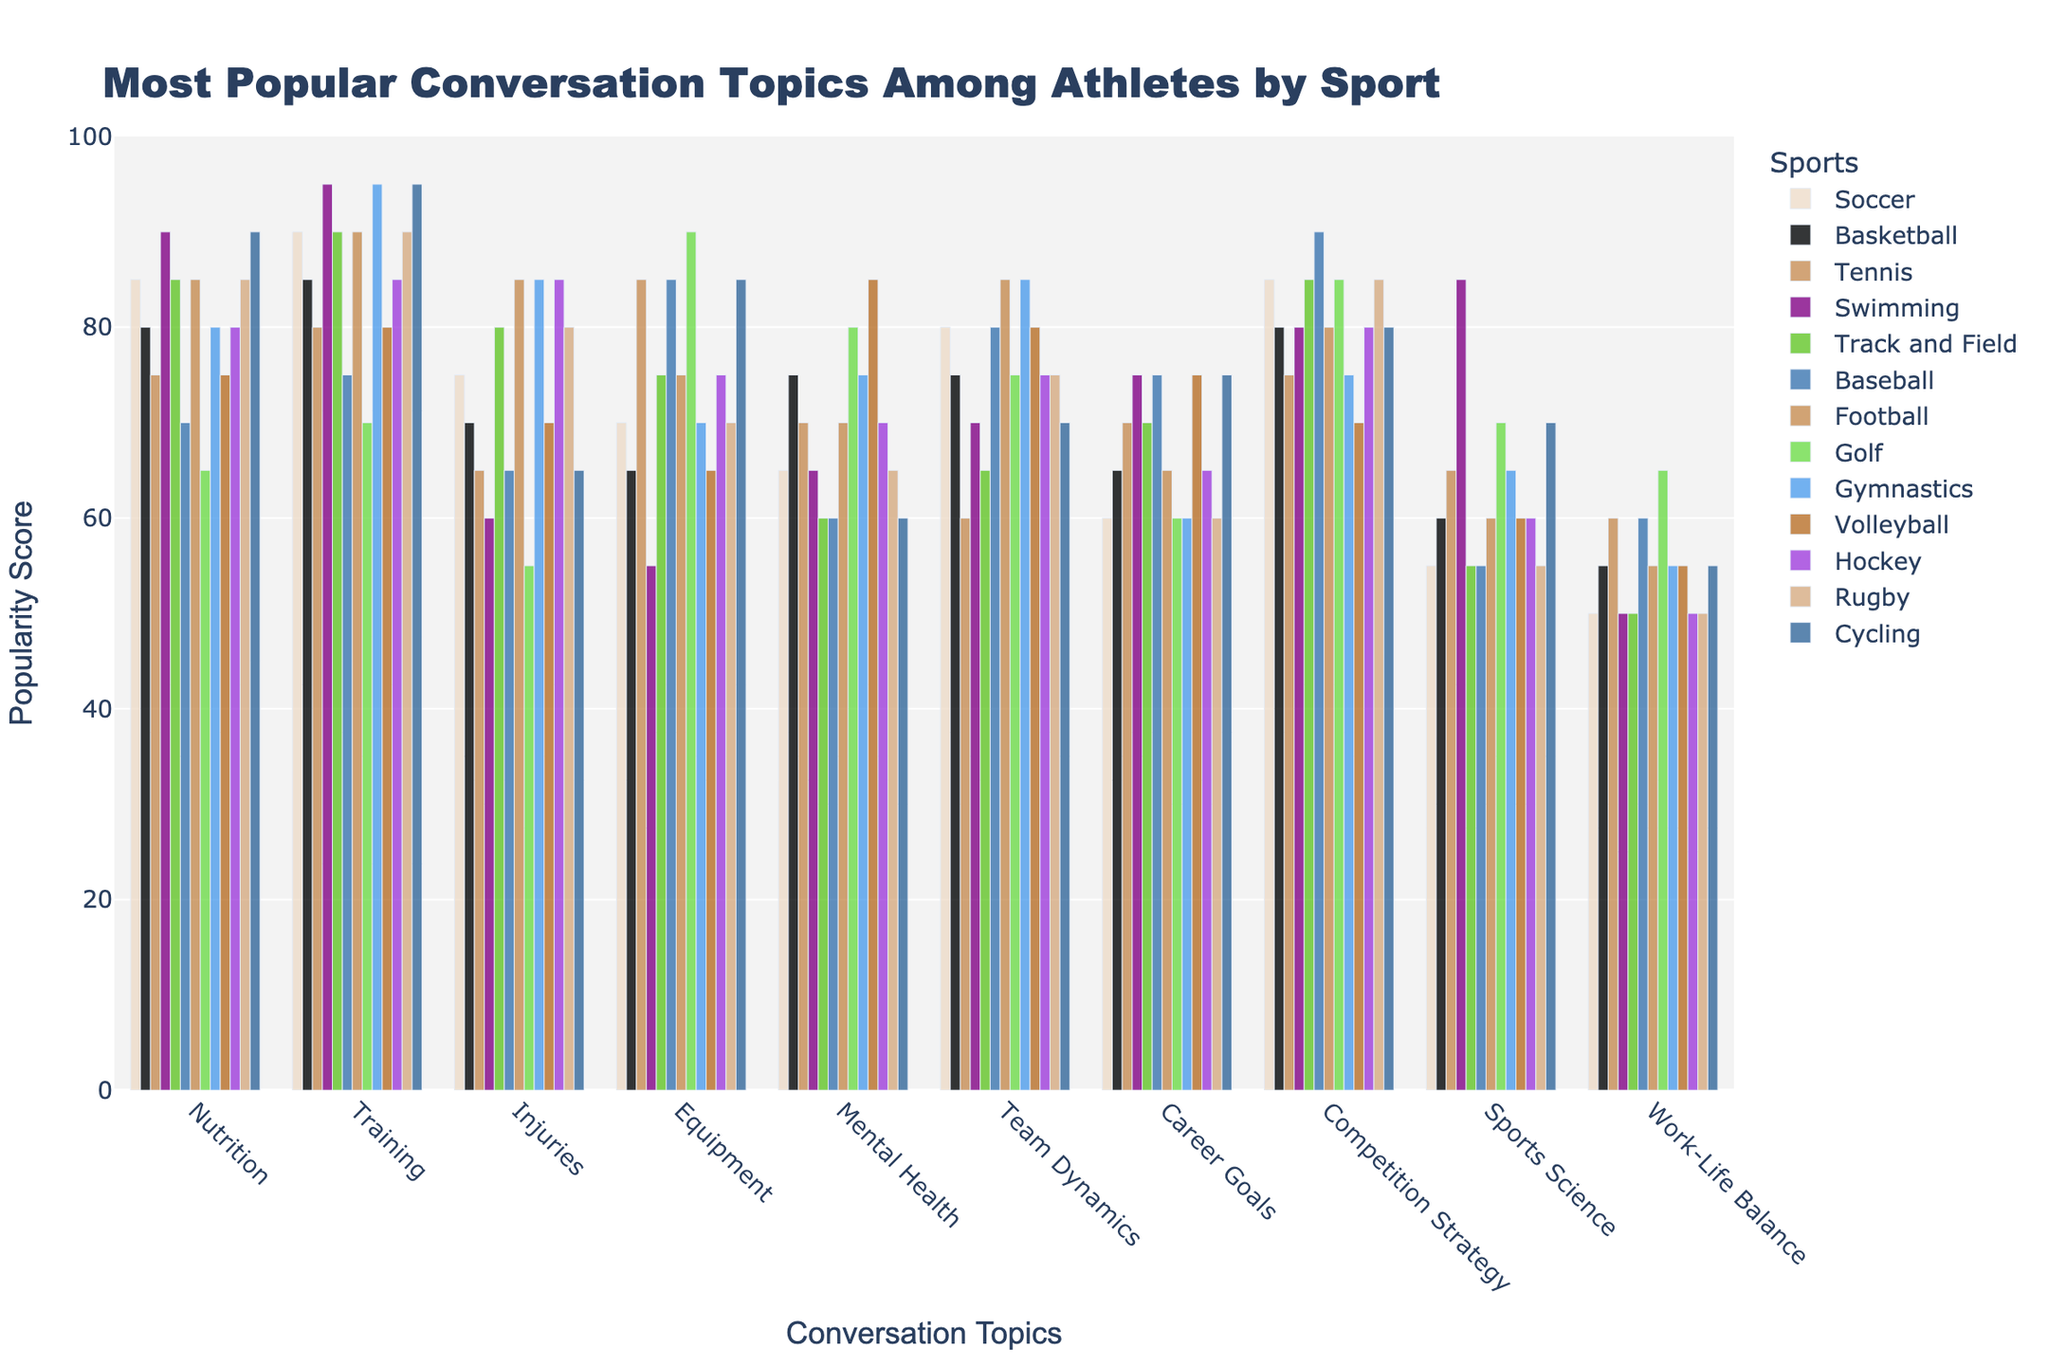Which sport has the highest popularity score for Mental Health? Soccer has a score of 65, Basketball 75, Tennis 70, Swimming 65, Track and Field 60, Baseball 60, Football 70, Golf 80, Gymnastics 75, Volleyball 85, Hockey 70, Rugby 65, and Cycling 60. Volleyball has the highest score of 85.
Answer: Volleyball Which sport has the lowest average popularity score across all topics? Calculate the average score for each sport: Soccer (73.5), Basketball (71), Tennis (70), Swimming (73.5), Track and Field (71), Baseball (72.5), Football (74), Golf (74.5), Gymnastics (75.5), Volleyball (74.5), Hockey (72.5), Rugby (70), Cycling (73.5). Tennis and Rugby both have the lowest average score of 70.
Answer: Tennis and Rugby Which conversation topic has the highest popularity score across all sports? Check the highest scores for each topic: Nutrition (90), Training (95), Injuries (85), Equipment (90), Mental Health (85), Team Dynamics (85), Career Goals (75), Competition Strategy (90), Sports Science (85), Work-Life Balance (65). Training has the highest score of 95.
Answer: Training What is the difference in popularity score for Nutrition between the sport with the highest score and the one with the lowest? The highest score in Nutrition is for Swimming and Cycling (90), and the lowest is for Golf (65). The difference is 90 - 65 = 25.
Answer: 25 Which sport has the most balanced popularity scores across different topics? Look for the sport with the smallest range of values: Soccer (35), Basketball (30), Tennis (25), Swimming (40), Track and Field (30), Baseball (30), Football (30), Golf (35), Gymnastics (35), Volleyball (30), Hockey (35), Rugby (35), Cycling (35). Tennis has the smallest range of 25 points (from 55 to 85).
Answer: Tennis Which sport has the highest combined score for Nutrition, Training, and Injuries? Soccer (250), Basketball (235), Tennis (220), Swimming (245), Track and Field (255), Baseball (220), Football (260), Golf (190), Gymnastics (260), Volleyball (225), Hockey (250), Rugby (255), Cycling (250). Football and Gymnastics both have the highest combined score of 260.
Answer: Football and Gymnastics Comparing Soccer and Basketball, which sport is more popular for Team Dynamics? Soccer has a score of 80, and Basketball has a score of 75. Soccer has the higher score.
Answer: Soccer For Track and Field, what is the average popularity score for Equipment and Competition Strategy? Scores for Equipment and Competition Strategy are 75 and 85, respectively. The average is (75 + 85) / 2 = 80.
Answer: 80 